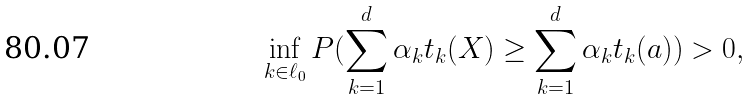Convert formula to latex. <formula><loc_0><loc_0><loc_500><loc_500>\inf _ { k \in \ell _ { 0 } } P ( \sum _ { k = 1 } ^ { d } \alpha _ { k } t _ { k } ( X ) \geq \sum _ { k = 1 } ^ { d } \alpha _ { k } t _ { k } ( a ) ) > 0 ,</formula> 